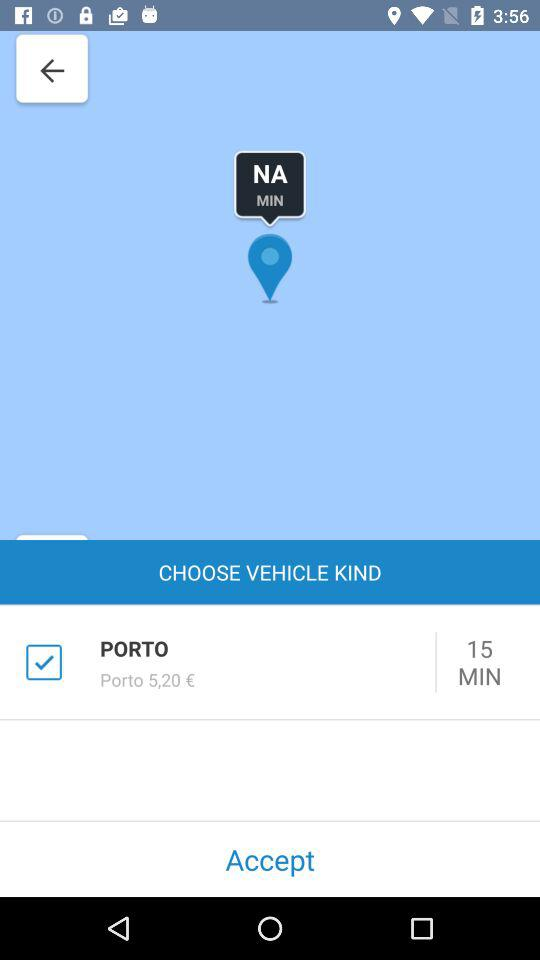What is the given duration? The given duration is 15 minutes. 